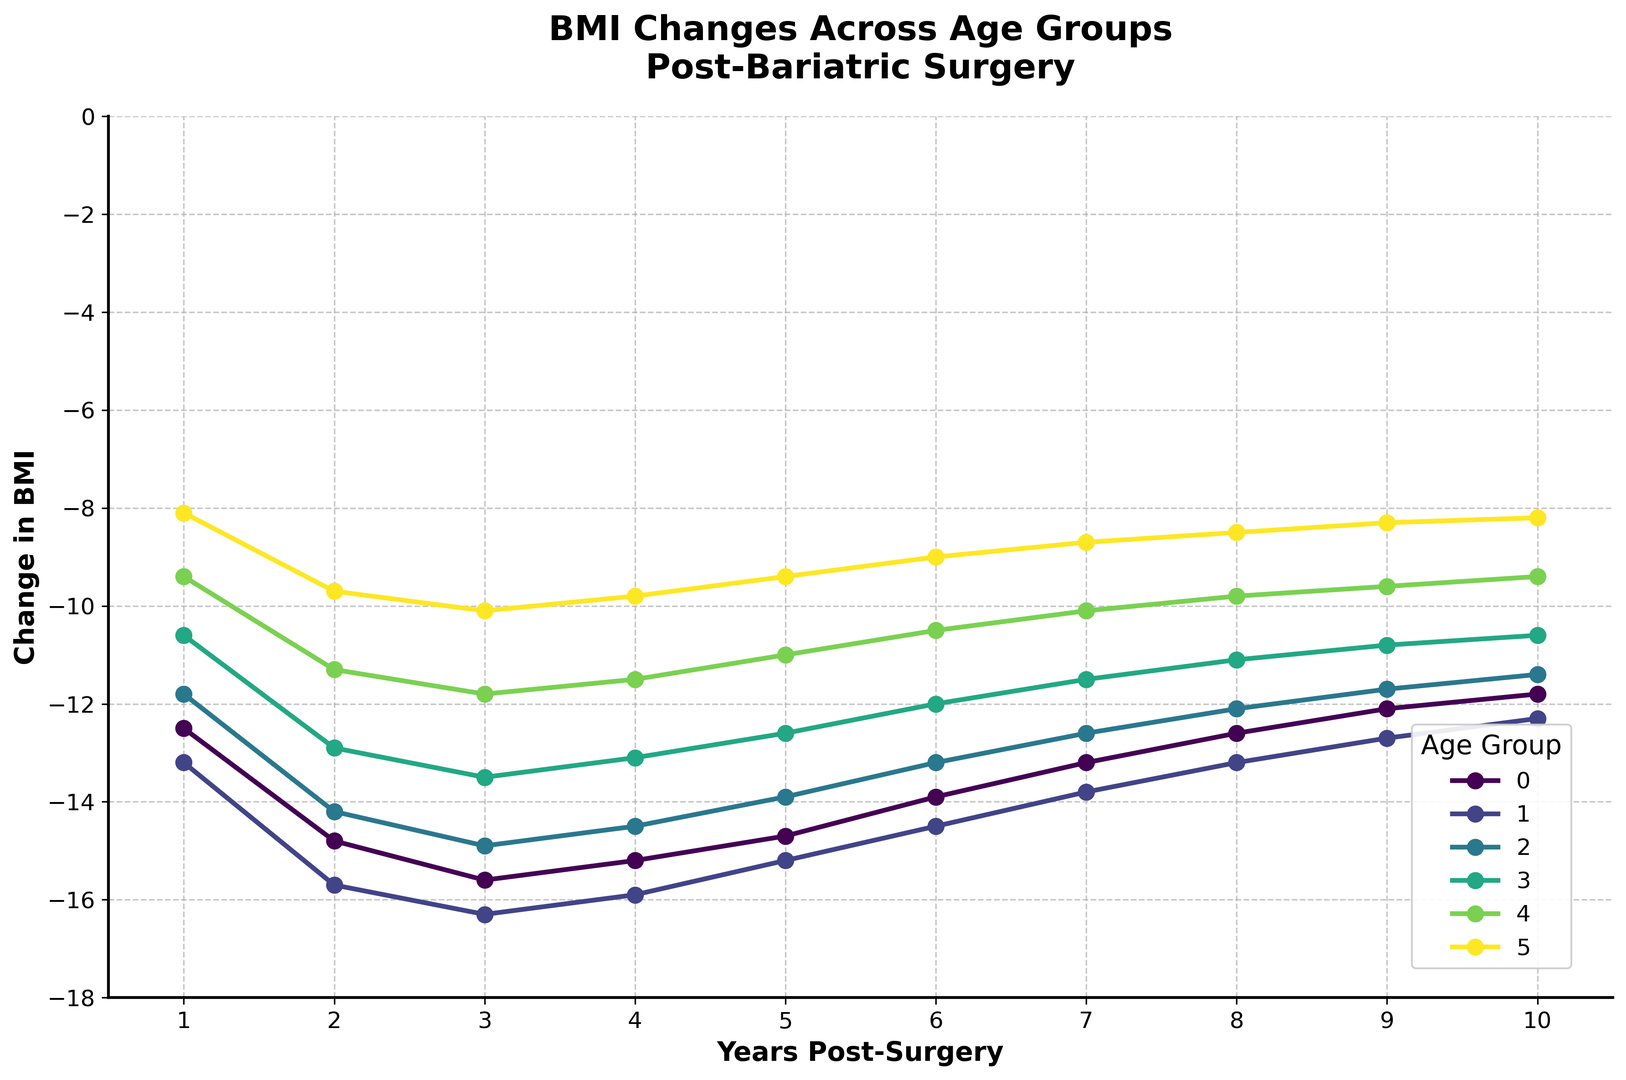what is the general trend in BMI changes for the 18-25 age group over the 10-year period? The line for the 18-25 age group starts at -12.5 at 1 year and decreases to -11.8 at 10 years. Despite the fluctuation, the overall trend shows a slight decrease in the change of BMI over the 10-year period.
Answer: A slight decrease in change of BMI which age group experienced the greatest reduction in BMI at 2 years post-surgery? Looking at the plot, the 26-35 age group shows the lowest value at 2 years post-surgery with -15.7.
Answer: 26-35 how does the BMI change for the 65+ age group in the last 5 years compare to the first 5 years? In the first 5 years, the changes are -8.1, -9.7, -10.1, -9.8, and -9.4. In the last 5 years, they are -9.0, -8.7, -8.5, -8.3, and -8.2. The BMI reduction is less steep in the last 5 years compared to the first 5 years.
Answer: Less steep in the last 5 years which age group shows the smallest change in BMI after 10 years? The 65+ age group shows the smallest change in BMI after 10 years with a value of -8.2.
Answer: 65+ between the 36-45 and 46-55 age groups, which has a steeper initial decrease in BMI in the first 3 years? At 1, 2, and 3 years, the 36-45 age group has changes of -11.8, -14.2, and -14.9. The 46-55 age group has changes of -10.6, -12.9, and -13.5. The 36-45 age group has a steeper initial decrease in BMI over the first 3 years.
Answer: 36-45 which age group maintains the greatest BMI reduction consistently from years 4 to 10? The 26-35 age group maintains a consistent and greater reduction in BMI ranging from -15.9 at 4 years to -12.3 at 10 years, consistently outperforming other groups.
Answer: 26-35 how does the BMI change for the 26-35 age group at year 4 compare to the 18-25 age group at year 4? At year 4, the 26-35 age group has a BMI change of -15.9, while the 18-25 age group has a BMI change of -15.2. The 26-35 age group shows a greater reduction.
Answer: -15.9 vs -15.2 which age group displays the most noticeable trend reversal (from decreasing to increasing BMI reduction) and in which year does it occur? The 18-25 age group displays the most noticeable trend reversal. From year 3 to year 4, the BMI reduction decreases slightly from -15.6 to -15.2, then continues to decrease at a smaller rate.
Answer: 18-25 between years 3-4 